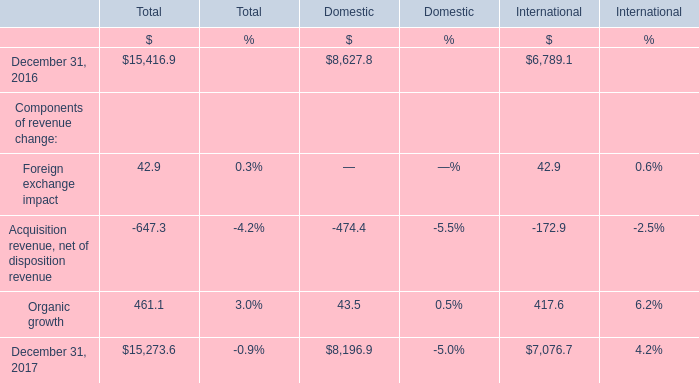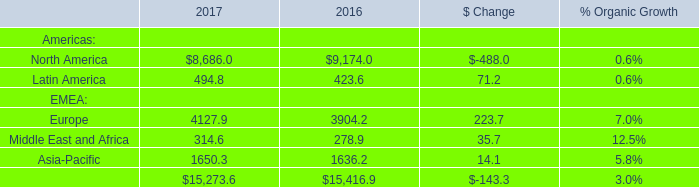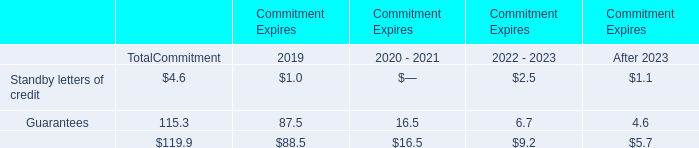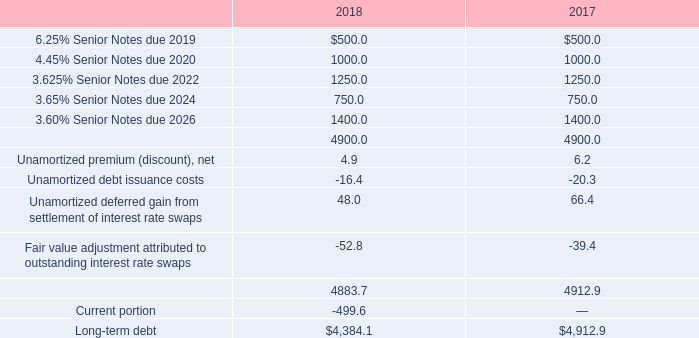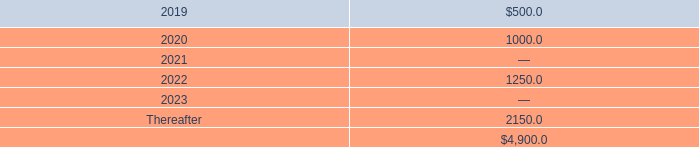In the year with higher total value, what's the amount of the value in terms of Asia-Pacific? 
Answer: 1636.2. 